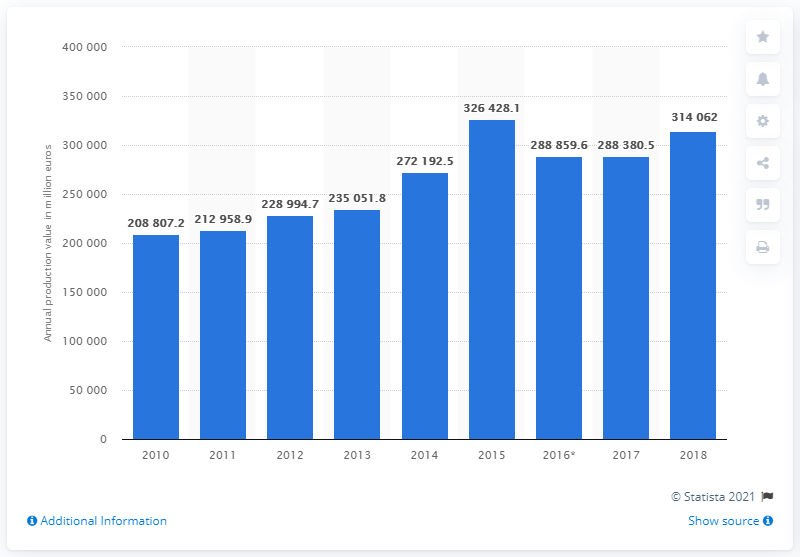Outline some significant characteristics in this image. In 2016, the production value of the construction industry in the UK was 314,062,000. The production value of the construction industry in 2016 was 288,380.5. 